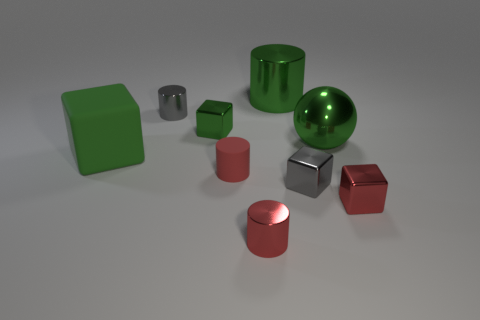Subtract 1 cubes. How many cubes are left? 3 Subtract all green cylinders. How many cylinders are left? 3 Subtract all yellow cylinders. Subtract all yellow blocks. How many cylinders are left? 4 Add 1 red matte balls. How many objects exist? 10 Subtract all spheres. How many objects are left? 8 Add 1 tiny gray cylinders. How many tiny gray cylinders exist? 2 Subtract 0 brown spheres. How many objects are left? 9 Subtract all green metal objects. Subtract all green spheres. How many objects are left? 5 Add 3 small red matte cylinders. How many small red matte cylinders are left? 4 